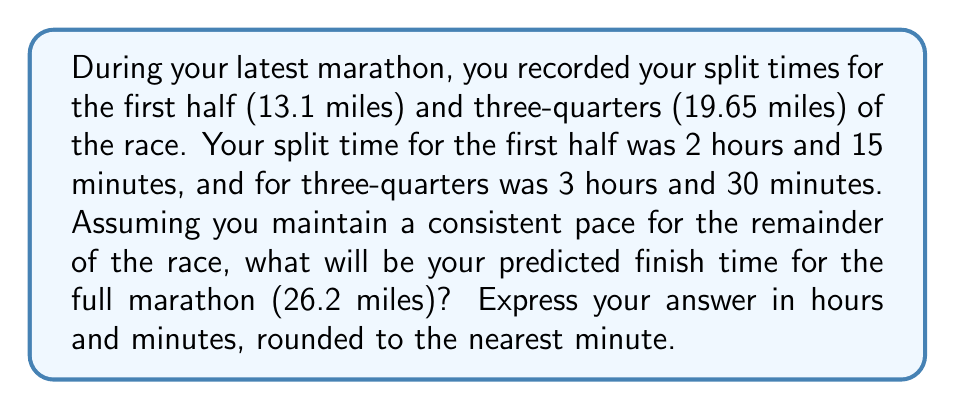Show me your answer to this math problem. Let's approach this step-by-step:

1) First, we need to calculate your pace for the last quarter of the race. We'll use the time between the halfway point and the three-quarter point for this.

   Time for second quarter = 3:30 - 2:15 = 1:15 (75 minutes)

2) Now, let's calculate the pace per quarter marathon:
   $$ \text{Pace per quarter} = \frac{75 \text{ minutes}}{1 \text{ quarter}} = 75 \text{ min/quarter} $$

3) Assuming you maintain this pace for the last quarter, we can predict your time for the full marathon:

   $$ \text{Full marathon time} = 3:30 + 75 \text{ minutes} = 3:30 + 1:15 = 4:45 $$

4) To verify, let's break down the full time:
   - First half (2 quarters): 2:15
   - Third quarter: 1:15
   - Fourth quarter: 1:15
   - Total: 2:15 + 1:15 + 1:15 = 4:45

Therefore, maintaining your current pace, you're predicted to finish the marathon in 4 hours and 45 minutes.
Answer: 4 hours 45 minutes 